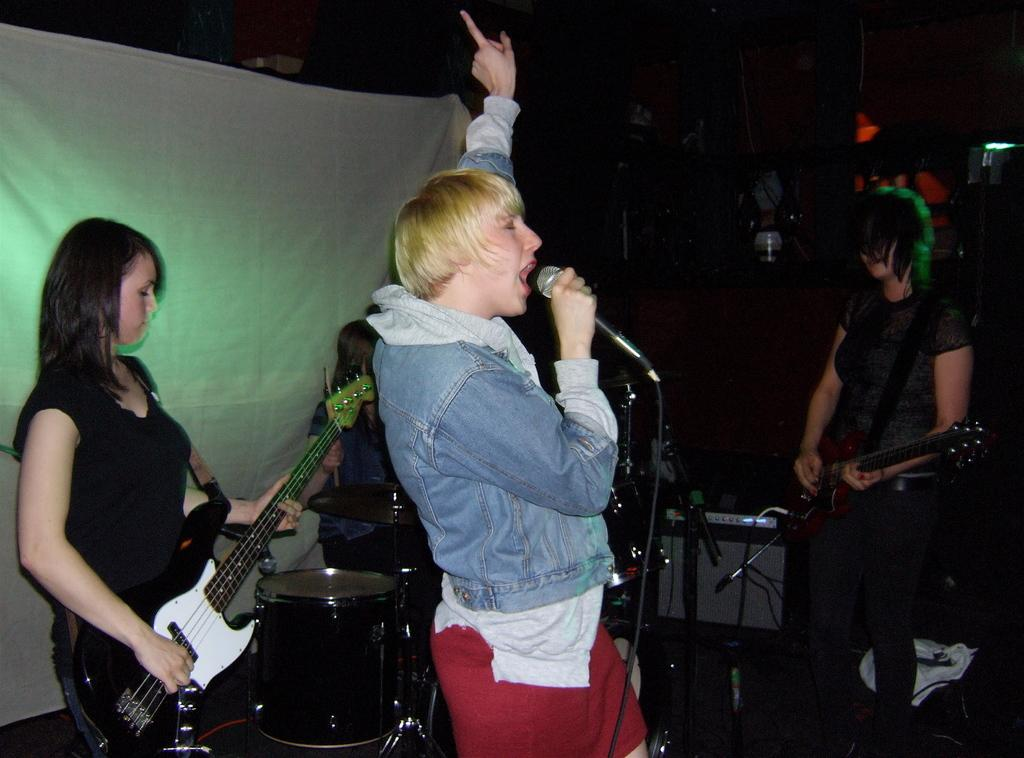How many women are present in the image? There are four women in the image. What are two of the women doing in the image? Two of the women are playing guitar. What is the third woman doing in the image? One woman is playing drums. What is the fourth woman doing in the image? One woman is singing on a microphone. What can be seen in the background of the image? There is cloth visible in the background. How would you describe the overall appearance of the image? The image has a dark appearance. How many mice can be seen running around the room in the image? There are no mice present in the image, nor is there a room visible. 